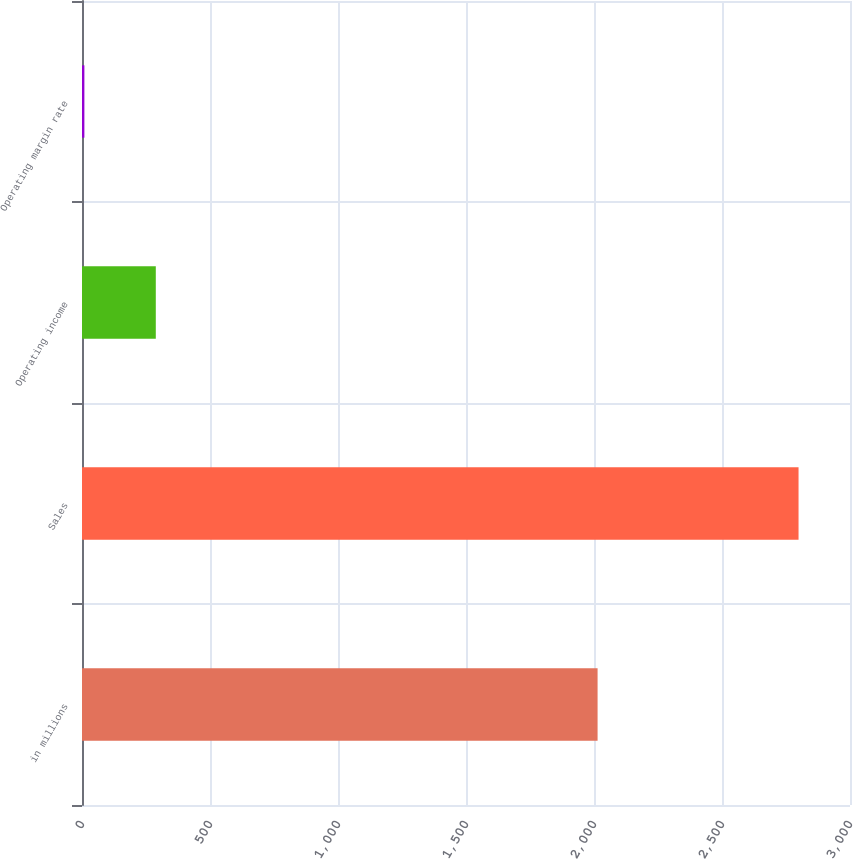Convert chart to OTSL. <chart><loc_0><loc_0><loc_500><loc_500><bar_chart><fcel>in millions<fcel>Sales<fcel>Operating income<fcel>Operating margin rate<nl><fcel>2014<fcel>2799<fcel>288.27<fcel>9.3<nl></chart> 